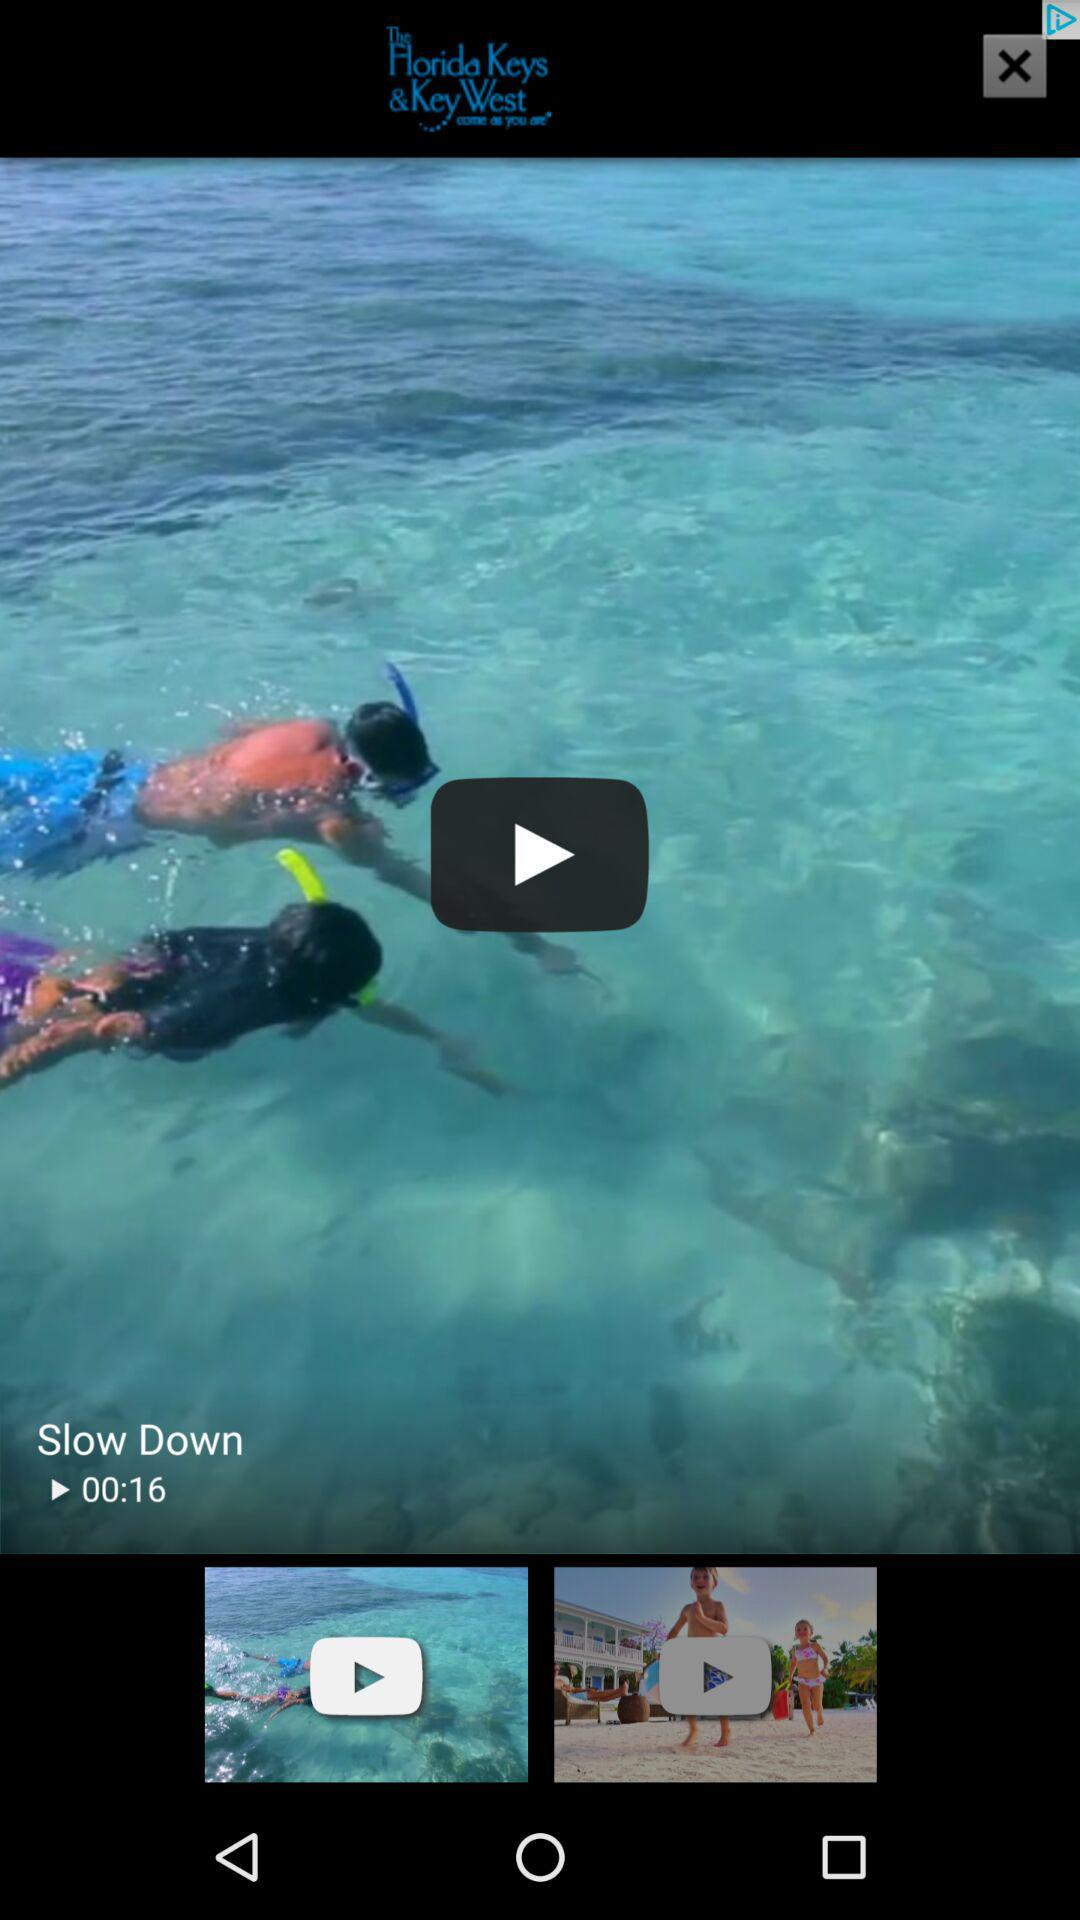What is the total duration of the video? The total duration of the video is 16 seconds. 